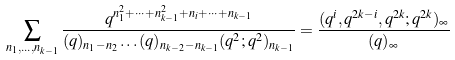<formula> <loc_0><loc_0><loc_500><loc_500>\sum _ { n _ { 1 } , \dots , n _ { k - 1 } } \frac { q ^ { n _ { 1 } ^ { 2 } + \cdots + n _ { k - 1 } ^ { 2 } + n _ { i } + \cdots + n _ { k - 1 } } } { ( q ) _ { n _ { 1 } - n _ { 2 } } \dots ( q ) _ { n _ { k - 2 } - n _ { k - 1 } } ( q ^ { 2 } ; q ^ { 2 } ) _ { n _ { k - 1 } } } = \frac { ( q ^ { i } , q ^ { 2 k - i } , q ^ { 2 k } ; q ^ { 2 k } ) _ { \infty } } { ( q ) _ { \infty } }</formula> 